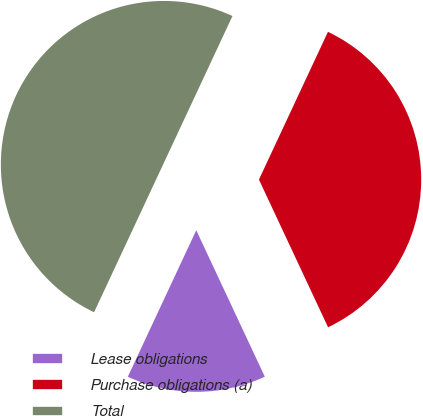<chart> <loc_0><loc_0><loc_500><loc_500><pie_chart><fcel>Lease obligations<fcel>Purchase obligations (a)<fcel>Total<nl><fcel>13.95%<fcel>36.05%<fcel>50.0%<nl></chart> 